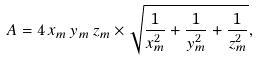<formula> <loc_0><loc_0><loc_500><loc_500>A = 4 \, x _ { m } \, y _ { m } \, z _ { m } \times { \sqrt { { \frac { 1 } { x _ { m } ^ { 2 } } } + { \frac { 1 } { y _ { m } ^ { 2 } } } + { \frac { 1 } { z _ { m } ^ { 2 } } } } } ,</formula> 